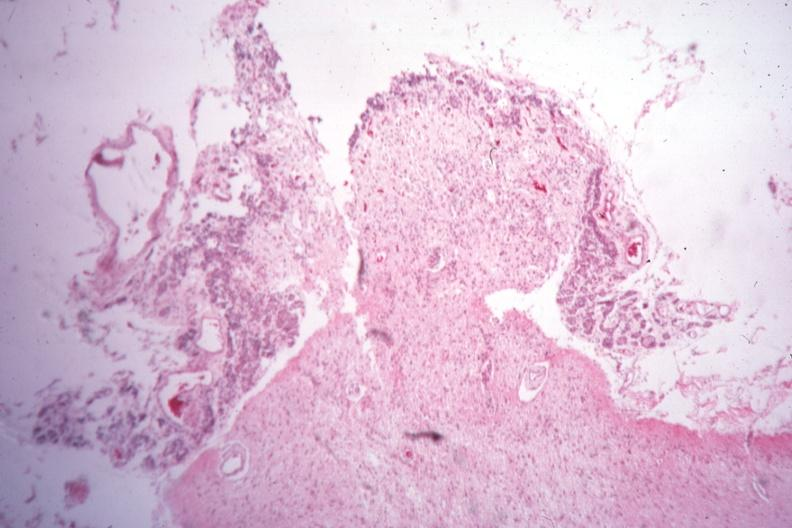s pituitectomy present?
Answer the question using a single word or phrase. Yes 